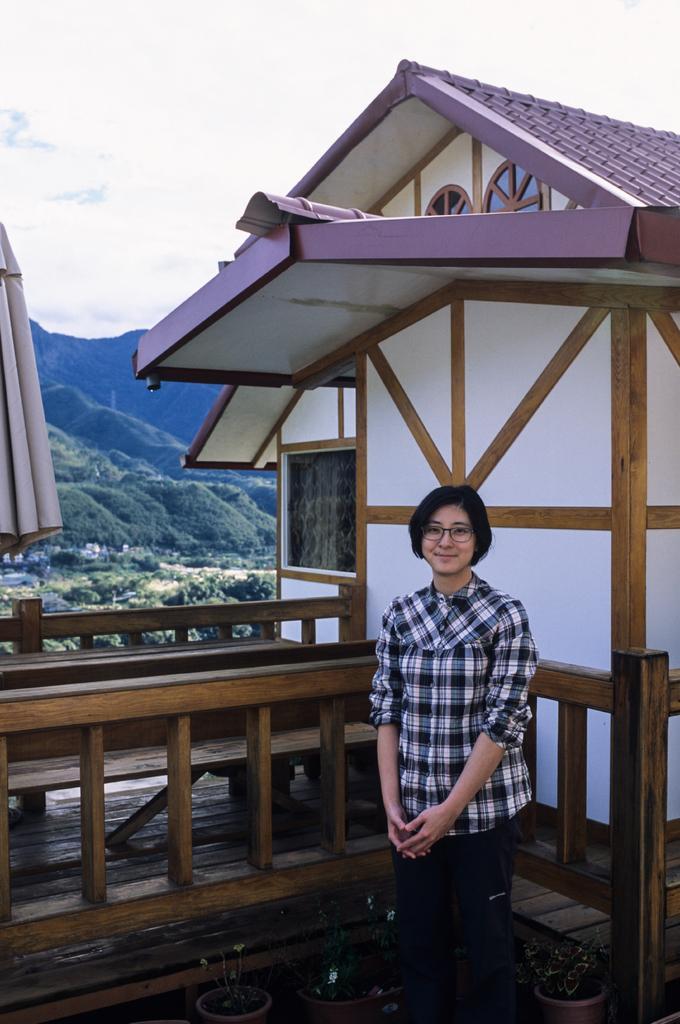How would you summarize this image in a sentence or two? In this image we can see a woman wearing a dress and spectacles is standing in front of a building. On the left side, we can see a wooden railing and a tent. In the foreground we can see group of plants. In the background, we can see a group of trees and the sky. 